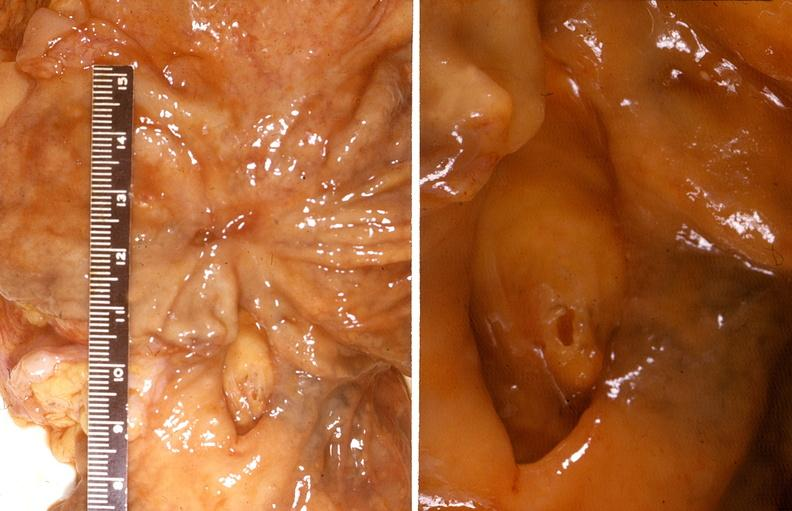does this image show stomach, healed peptic ulcer and bleeding duodenal ulcer?
Answer the question using a single word or phrase. Yes 